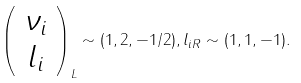Convert formula to latex. <formula><loc_0><loc_0><loc_500><loc_500>\left ( \begin{array} { c } \nu _ { i } \\ l _ { i } \end{array} \right ) _ { L } \sim ( 1 , 2 , - 1 / 2 ) , l _ { i R } \sim ( 1 , 1 , - 1 ) .</formula> 